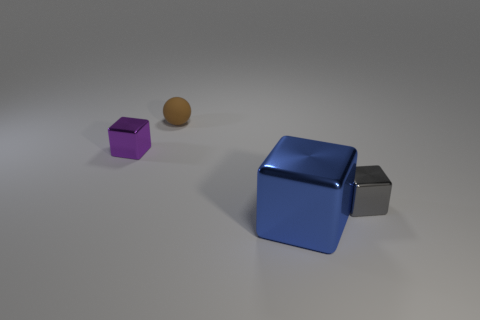There is a object that is on the left side of the brown sphere; what is it made of?
Provide a short and direct response. Metal. The purple shiny object has what size?
Offer a terse response. Small. What number of cyan objects are tiny matte cubes or cubes?
Your answer should be very brief. 0. There is a shiny block behind the tiny cube that is right of the small purple shiny block; what size is it?
Make the answer very short. Small. Does the big metal object have the same color as the metal block that is to the left of the tiny matte ball?
Offer a terse response. No. How many other objects are the same material as the gray block?
Your response must be concise. 2. There is a tiny thing that is the same material as the tiny gray block; what is its shape?
Your response must be concise. Cube. Is there any other thing of the same color as the matte thing?
Make the answer very short. No. Is the number of big blue metal things that are on the right side of the big shiny cube greater than the number of tiny matte spheres?
Offer a terse response. No. Does the big blue metallic object have the same shape as the tiny gray object in front of the purple shiny block?
Provide a succinct answer. Yes. 